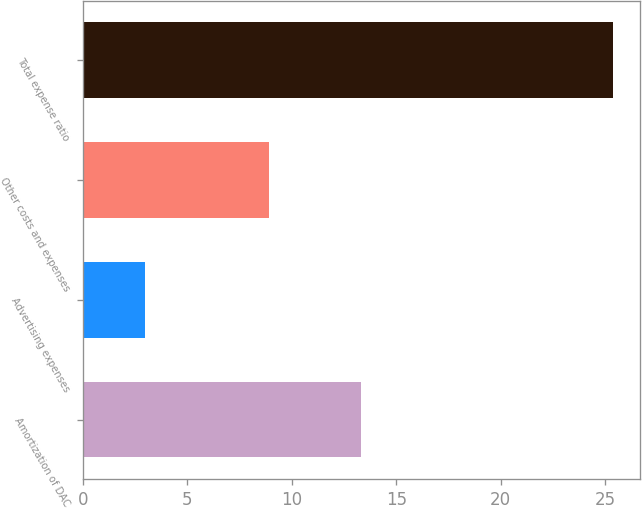Convert chart to OTSL. <chart><loc_0><loc_0><loc_500><loc_500><bar_chart><fcel>Amortization of DAC<fcel>Advertising expenses<fcel>Other costs and expenses<fcel>Total expense ratio<nl><fcel>13.3<fcel>3<fcel>8.9<fcel>25.4<nl></chart> 